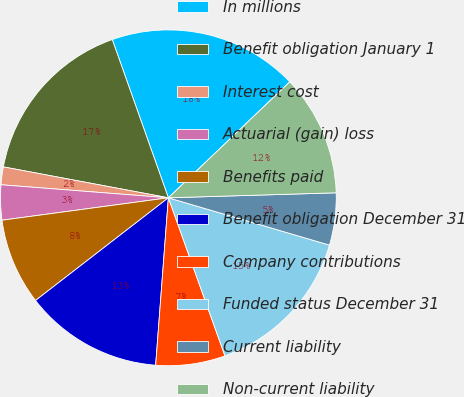<chart> <loc_0><loc_0><loc_500><loc_500><pie_chart><fcel>In millions<fcel>Benefit obligation January 1<fcel>Interest cost<fcel>Actuarial (gain) loss<fcel>Benefits paid<fcel>Benefit obligation December 31<fcel>Company contributions<fcel>Funded status December 31<fcel>Current liability<fcel>Non-current liability<nl><fcel>18.29%<fcel>16.63%<fcel>1.71%<fcel>3.37%<fcel>8.34%<fcel>13.32%<fcel>6.68%<fcel>14.98%<fcel>5.02%<fcel>11.66%<nl></chart> 